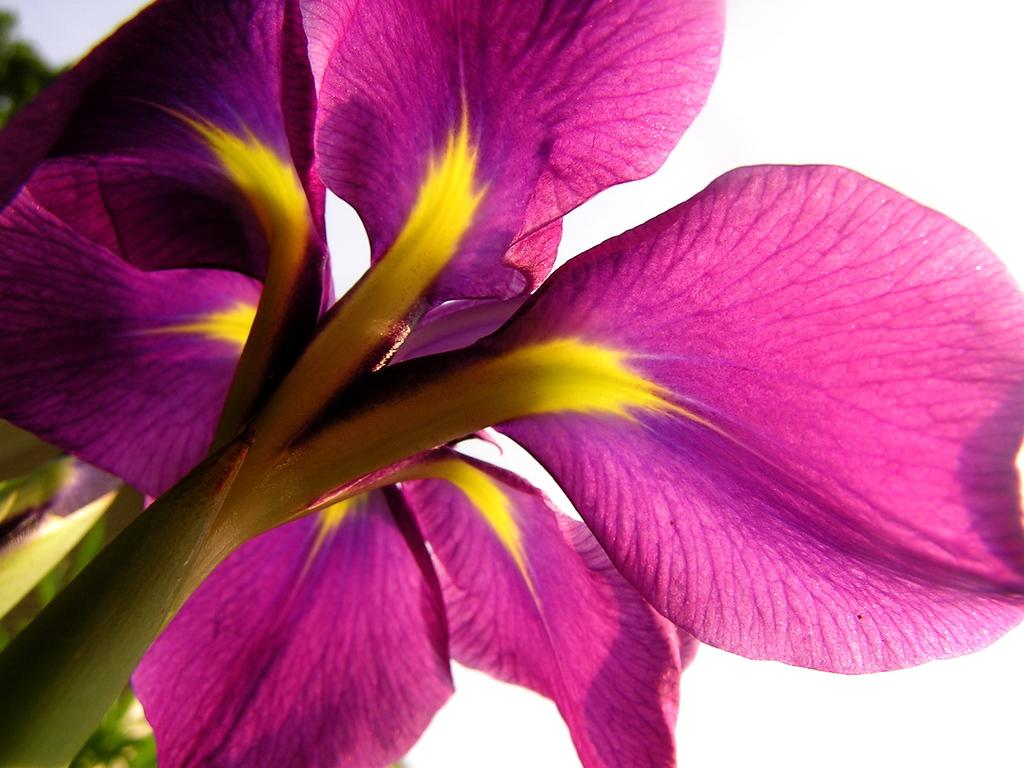What type of flower is present in the image? There is a pink flower in the image. How many lizards can be seen climbing the pink flower in the image? There are no lizards present in the image; it only features a pink flower. What type of attraction is associated with the pink flower in the image? The image does not depict any attractions or events related to the pink flower. 